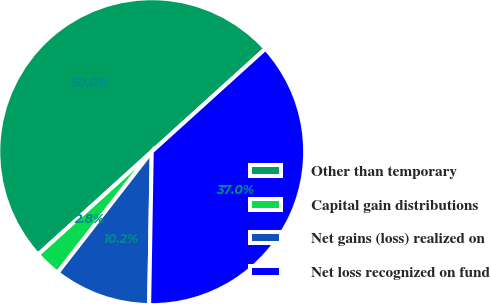Convert chart. <chart><loc_0><loc_0><loc_500><loc_500><pie_chart><fcel>Other than temporary<fcel>Capital gain distributions<fcel>Net gains (loss) realized on<fcel>Net loss recognized on fund<nl><fcel>50.0%<fcel>2.77%<fcel>10.25%<fcel>36.98%<nl></chart> 